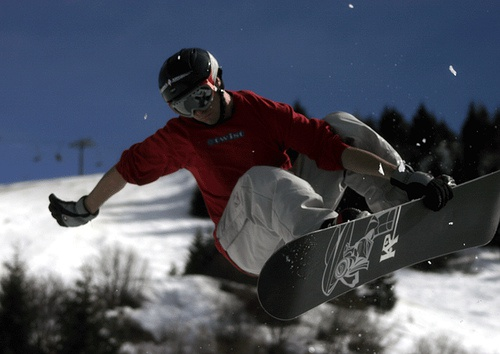Describe the objects in this image and their specific colors. I can see people in darkblue, black, gray, maroon, and blue tones and snowboard in darkblue, black, gray, and darkgray tones in this image. 